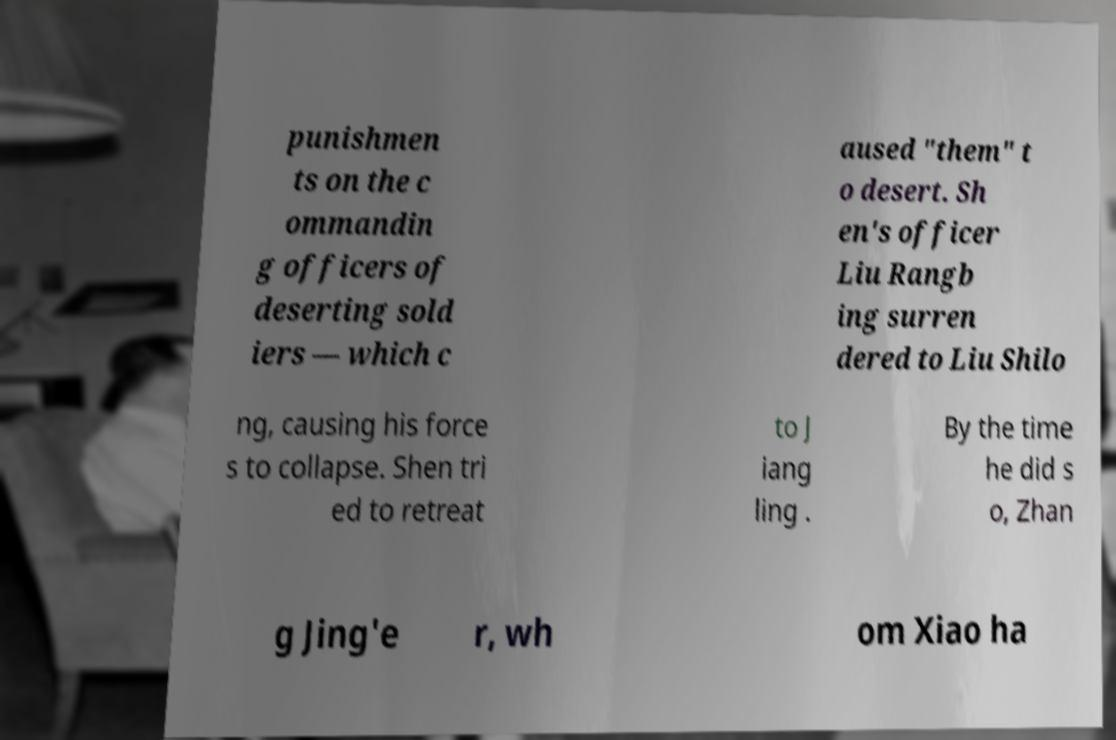There's text embedded in this image that I need extracted. Can you transcribe it verbatim? punishmen ts on the c ommandin g officers of deserting sold iers — which c aused "them" t o desert. Sh en's officer Liu Rangb ing surren dered to Liu Shilo ng, causing his force s to collapse. Shen tri ed to retreat to J iang ling . By the time he did s o, Zhan g Jing'e r, wh om Xiao ha 